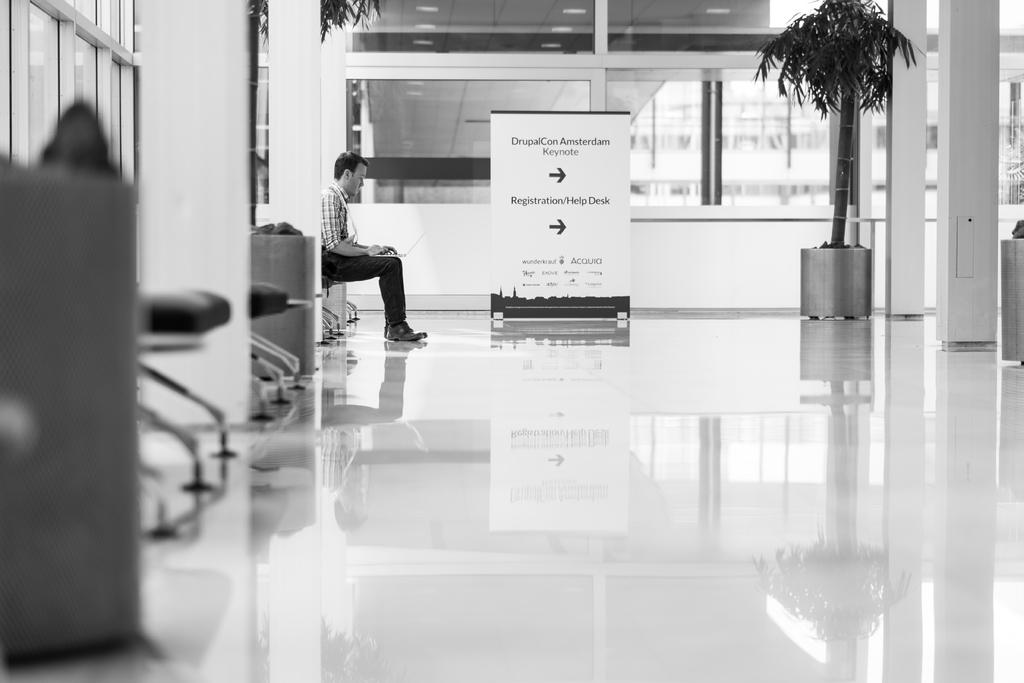What is the color scheme of the image? The image is in black and white. What can be seen in the foreground of the image? There is a floor in the foreground of the image. Where are the chairs located in the image? The chairs are on the left side of the image. What is the man in the image doing? A man is sitting with a laptop in the image. What is hanging or displayed in the image? There is a banner in the image. What type of vegetation is present in the image? There are plants in the image. What type of cap is the governor wearing in the image? There is no governor or cap present in the image. 